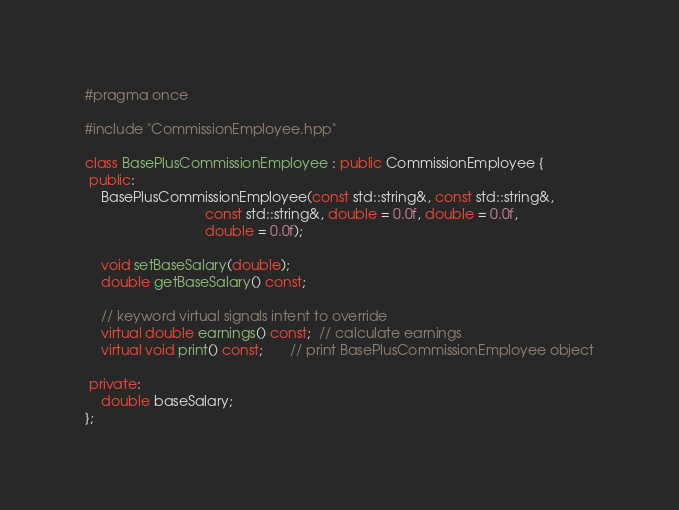<code> <loc_0><loc_0><loc_500><loc_500><_C++_>#pragma once

#include "CommissionEmployee.hpp"

class BasePlusCommissionEmployee : public CommissionEmployee {
 public:
    BasePlusCommissionEmployee(const std::string&, const std::string&,
                               const std::string&, double = 0.0f, double = 0.0f,
                               double = 0.0f);

    void setBaseSalary(double);
    double getBaseSalary() const;

    // keyword virtual signals intent to override
    virtual double earnings() const;  // calculate earnings
    virtual void print() const;       // print BasePlusCommissionEmployee object

 private:
    double baseSalary;
};
</code> 